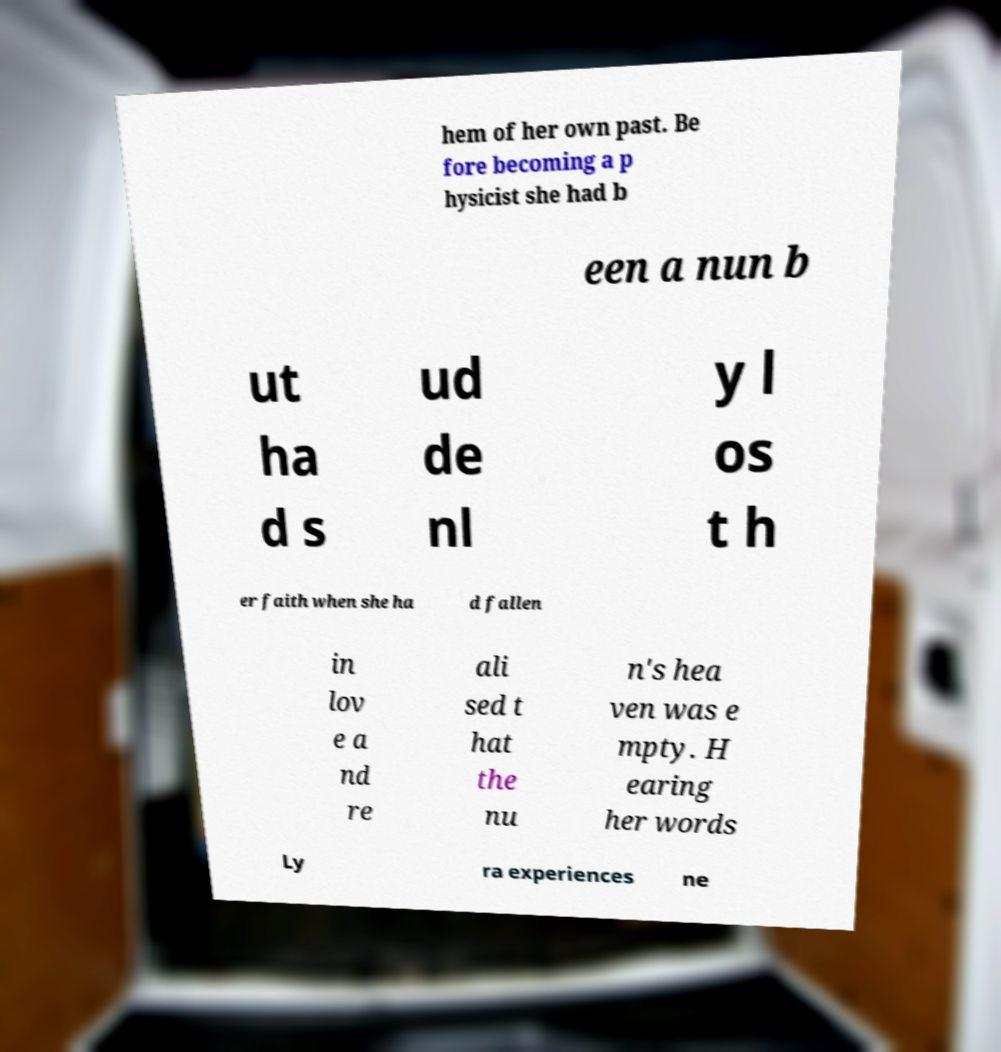Could you assist in decoding the text presented in this image and type it out clearly? hem of her own past. Be fore becoming a p hysicist she had b een a nun b ut ha d s ud de nl y l os t h er faith when she ha d fallen in lov e a nd re ali sed t hat the nu n's hea ven was e mpty. H earing her words Ly ra experiences ne 